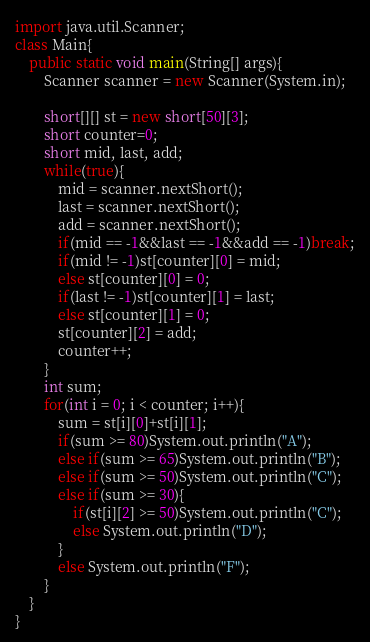<code> <loc_0><loc_0><loc_500><loc_500><_Java_>import java.util.Scanner;
class Main{
    public static void main(String[] args){
        Scanner scanner = new Scanner(System.in);

        short[][] st = new short[50][3];
        short counter=0;
        short mid, last, add;
        while(true){
            mid = scanner.nextShort();
            last = scanner.nextShort();
            add = scanner.nextShort();
            if(mid == -1&&last == -1&&add == -1)break;
            if(mid != -1)st[counter][0] = mid;
            else st[counter][0] = 0;
            if(last != -1)st[counter][1] = last;
            else st[counter][1] = 0;
            st[counter][2] = add;
            counter++;
        }
        int sum;
        for(int i = 0; i < counter; i++){
            sum = st[i][0]+st[i][1];
            if(sum >= 80)System.out.println("A");
            else if(sum >= 65)System.out.println("B");
            else if(sum >= 50)System.out.println("C");
            else if(sum >= 30){
                if(st[i][2] >= 50)System.out.println("C");
                else System.out.println("D");
            }
            else System.out.println("F");
        }
    }
}

</code> 